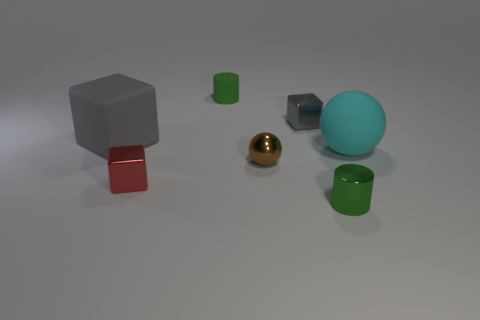Can you tell me the colors of the objects in the foreground? Certainly! In the foreground, there are two cylindrical objects that are both green in color. One of them is standing upright, and the other is lying on its side. 